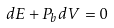Convert formula to latex. <formula><loc_0><loc_0><loc_500><loc_500>d E + P _ { b } d V = 0</formula> 